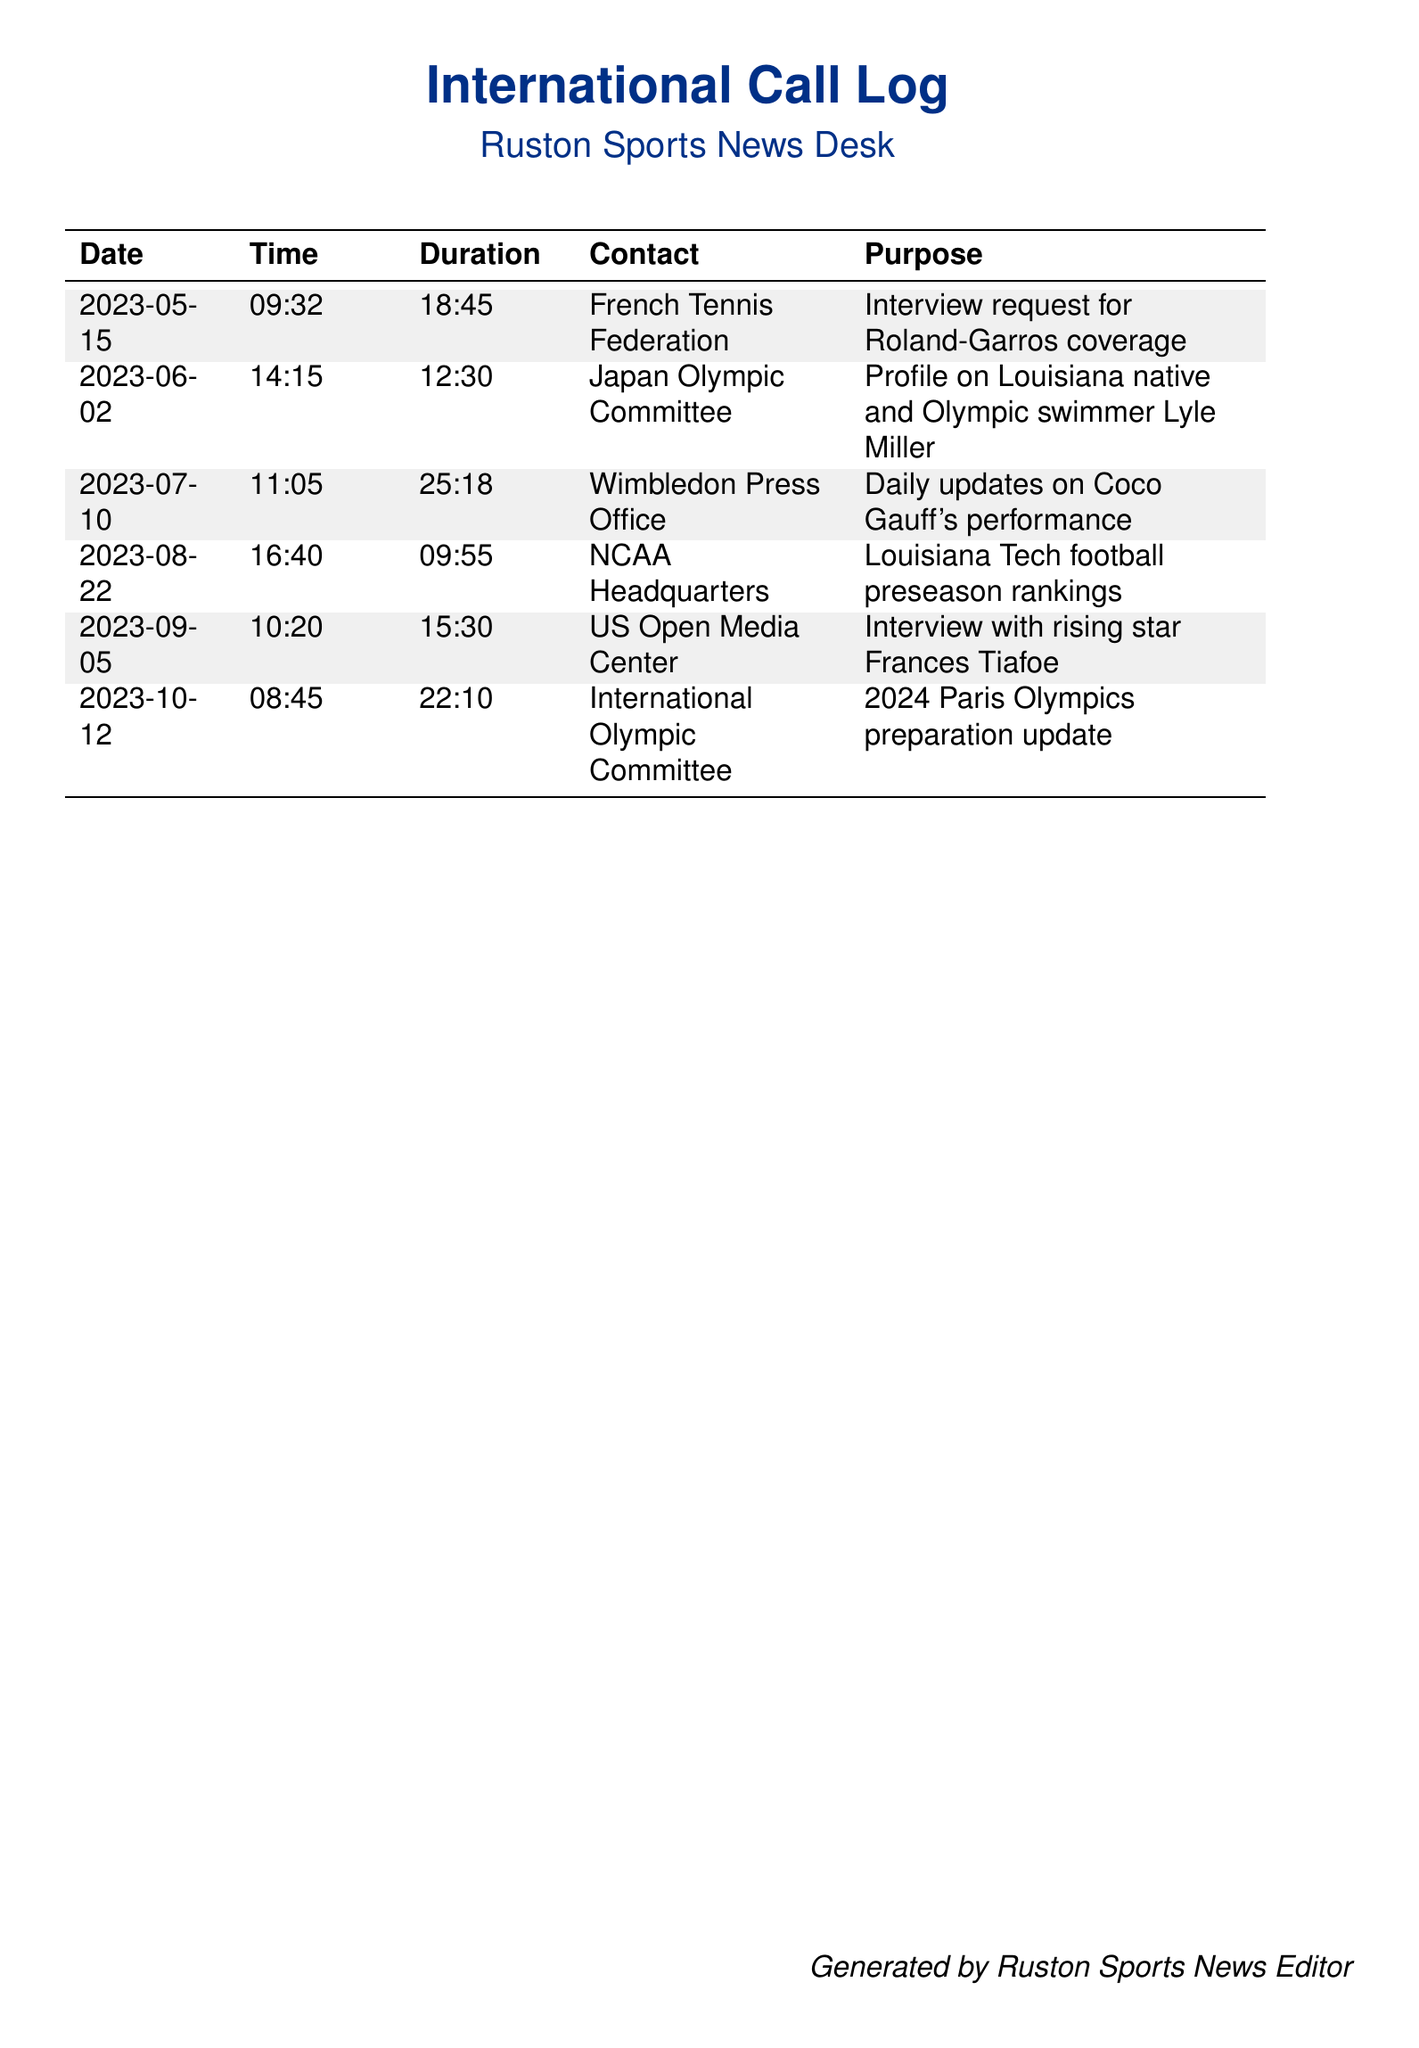What is the date of the call to the French Tennis Federation? The call to the French Tennis Federation was made on May 15, 2023, as shown in the document.
Answer: May 15, 2023 How long was the call to the Japan Olympic Committee? The duration of the call to the Japan Olympic Committee was recorded as 12:30 in the document.
Answer: 12:30 Who was interviewed for the US Open coverage? The document states that Frances Tiafoe was interviewed for the US Open coverage.
Answer: Frances Tiafoe What was the purpose of the call to the NCAA Headquarters? The purpose of the call to the NCAA Headquarters was to discuss Louisiana Tech football preseason rankings.
Answer: Louisiana Tech football preseason rankings Which event was the focus of the call on October 12, 2023? The call on October 12, 2023, focused on the preparation for the 2024 Paris Olympics according to the document.
Answer: 2024 Paris Olympics Which organization was contacted for Coco Gauff's performance updates? The Wimbledon Press Office was contacted for updates on Coco Gauff's performance, as indicated in the document.
Answer: Wimbledon Press Office How many calls were made for interviews with athletes or officials? There were a total of three calls specifically made for interviews with athletes or officials in the document.
Answer: Three What was the total duration of the calls listed in the document? The total duration of the calls can be summed up from individual durations given in the document; it adds up to 99:43.
Answer: 99:43 